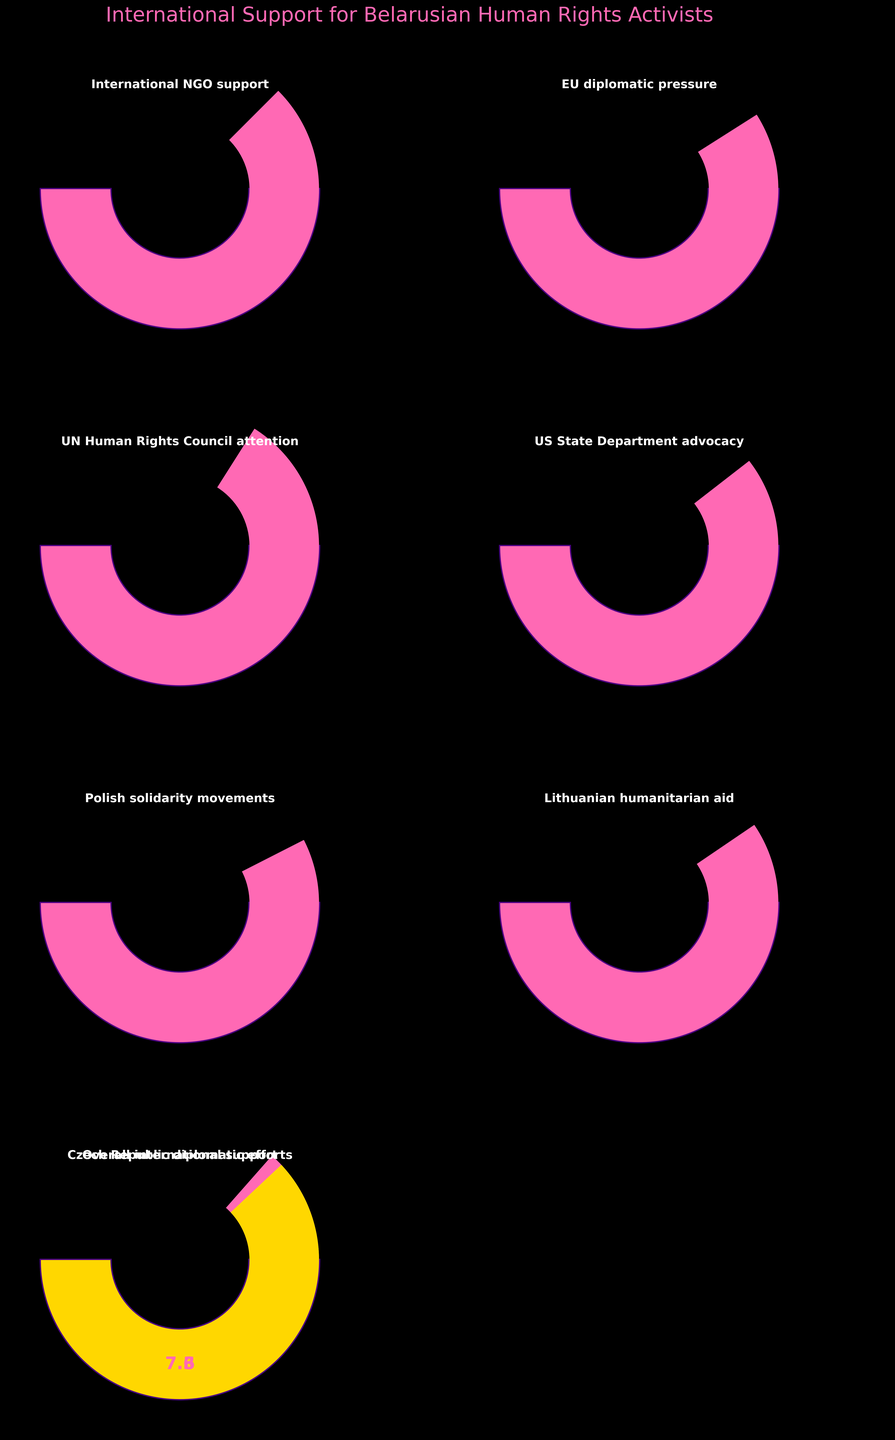What's the highest value of international support displayed in the figure? Refer to each gauge chart to find the one with the highest value. The Polish solidarity movements have the highest value, which is 8.5
Answer: 8.5 What's the overall value of international support? Look at the gauge labeled "Overall international support." The value shown is 7.6
Answer: 7.6 Which two levels of international support have values that differ the most? Compare each pair of values. The maximum difference is between Polish solidarity movements (8.5) and UN Human Rights Council attention (6.8), the difference being 1.7
Answer: Polish solidarity movements and UN Human Rights Council attention Is the EU diplomatic pressure more or less than the US State Department advocacy? Compare the values of EU diplomatic pressure (8.2) and US State Department advocacy (7.9). EU diplomatic pressure is higher
Answer: More What's the median value of all levels of international support shown? List each of the values and find the median: 7.3, 7.5, 7.6, 7.9, 8.1, 8.2, 8.5. The median value, which is the middle one in the ordered list, is 7.9
Answer: 7.9 How much higher is the value of Lithuanian humanitarian aid compared to the Czech Republic diplomatic efforts? Subtract the value of Czech Republic diplomatic efforts (7.3) from Lithuanian humanitarian aid (8.1). The difference is 0.8
Answer: 0.8 If you average the values of all individual support levels (excluding overall international support), what's the result? Sum all individual values (7.5 + 8.2 + 6.8 + 7.9 + 8.5 + 8.1 + 7.3 = 54.3) and divide by the number of values (7). The average is 54.3 / 7 = 7.7571
Answer: 7.76 (rounded to two decimal places) Which level of support is closest to the overall international support value? Refer to the gauge chart values. The value closest to the overall international support (7.6) is International NGO support (7.5)
Answer: International NGO support How does the UN Human Rights Council attention compare in its value to the average of all support levels (excluding overall international support)? First, calculate the average value, which is 7.76. The value of UN Human Rights Council attention (6.8) is less than the average
Answer: Less What is the range of the support values displayed? Determine the range by subtracting the smallest value (6.8) from the largest value (8.5). The range is 8.5 - 6.8 = 1.7
Answer: 1.7 